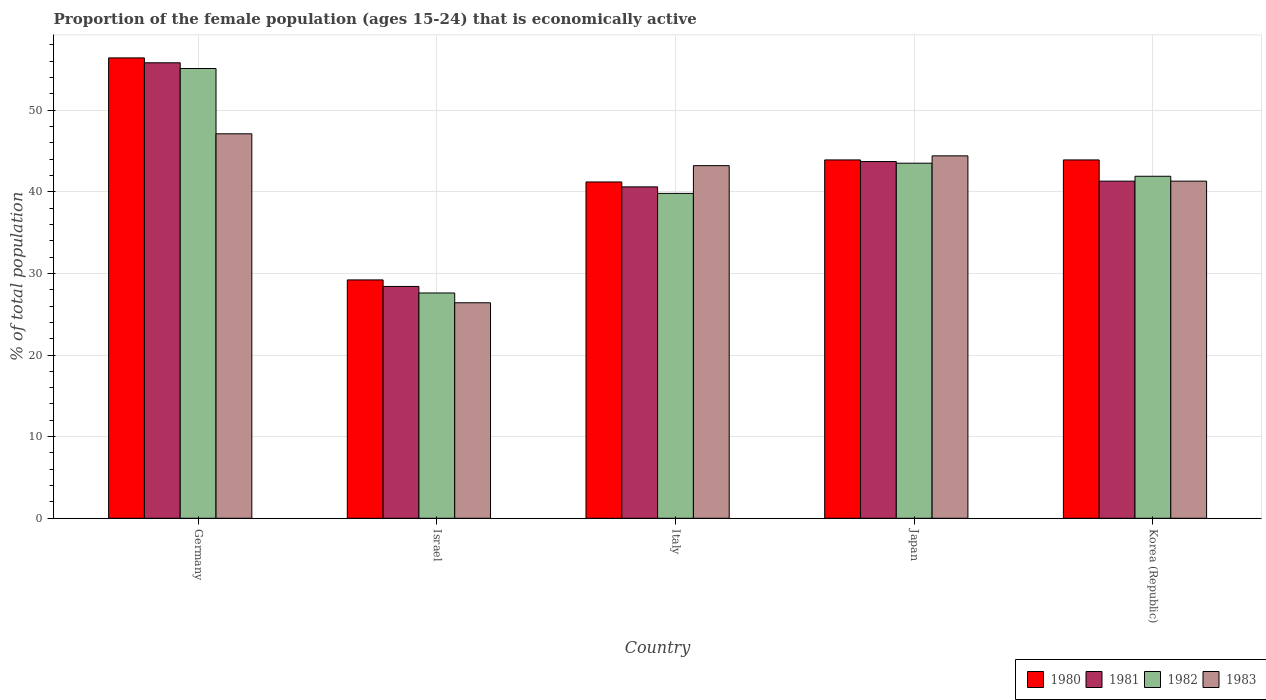How many groups of bars are there?
Keep it short and to the point. 5. Are the number of bars per tick equal to the number of legend labels?
Offer a very short reply. Yes. How many bars are there on the 1st tick from the left?
Provide a succinct answer. 4. How many bars are there on the 1st tick from the right?
Make the answer very short. 4. What is the label of the 5th group of bars from the left?
Make the answer very short. Korea (Republic). What is the proportion of the female population that is economically active in 1983 in Israel?
Your response must be concise. 26.4. Across all countries, what is the maximum proportion of the female population that is economically active in 1980?
Offer a terse response. 56.4. Across all countries, what is the minimum proportion of the female population that is economically active in 1981?
Offer a very short reply. 28.4. What is the total proportion of the female population that is economically active in 1980 in the graph?
Your answer should be compact. 214.6. What is the difference between the proportion of the female population that is economically active in 1983 in Germany and that in Israel?
Your response must be concise. 20.7. What is the difference between the proportion of the female population that is economically active in 1980 in Japan and the proportion of the female population that is economically active in 1982 in Germany?
Offer a very short reply. -11.2. What is the average proportion of the female population that is economically active in 1980 per country?
Give a very brief answer. 42.92. What is the difference between the proportion of the female population that is economically active of/in 1981 and proportion of the female population that is economically active of/in 1982 in Japan?
Provide a short and direct response. 0.2. What is the ratio of the proportion of the female population that is economically active in 1983 in Italy to that in Korea (Republic)?
Your answer should be compact. 1.05. What is the difference between the highest and the second highest proportion of the female population that is economically active in 1981?
Offer a very short reply. -2.4. What is the difference between the highest and the lowest proportion of the female population that is economically active in 1980?
Your response must be concise. 27.2. In how many countries, is the proportion of the female population that is economically active in 1980 greater than the average proportion of the female population that is economically active in 1980 taken over all countries?
Your answer should be compact. 3. Is the sum of the proportion of the female population that is economically active in 1981 in Israel and Italy greater than the maximum proportion of the female population that is economically active in 1983 across all countries?
Make the answer very short. Yes. Is it the case that in every country, the sum of the proportion of the female population that is economically active in 1982 and proportion of the female population that is economically active in 1980 is greater than the sum of proportion of the female population that is economically active in 1981 and proportion of the female population that is economically active in 1983?
Offer a very short reply. No. What does the 2nd bar from the left in Japan represents?
Your response must be concise. 1981. Is it the case that in every country, the sum of the proportion of the female population that is economically active in 1980 and proportion of the female population that is economically active in 1982 is greater than the proportion of the female population that is economically active in 1981?
Make the answer very short. Yes. How many countries are there in the graph?
Offer a terse response. 5. Are the values on the major ticks of Y-axis written in scientific E-notation?
Give a very brief answer. No. Does the graph contain any zero values?
Give a very brief answer. No. Does the graph contain grids?
Keep it short and to the point. Yes. Where does the legend appear in the graph?
Make the answer very short. Bottom right. How are the legend labels stacked?
Offer a terse response. Horizontal. What is the title of the graph?
Provide a succinct answer. Proportion of the female population (ages 15-24) that is economically active. What is the label or title of the X-axis?
Your answer should be compact. Country. What is the label or title of the Y-axis?
Provide a short and direct response. % of total population. What is the % of total population of 1980 in Germany?
Ensure brevity in your answer.  56.4. What is the % of total population of 1981 in Germany?
Give a very brief answer. 55.8. What is the % of total population of 1982 in Germany?
Keep it short and to the point. 55.1. What is the % of total population in 1983 in Germany?
Keep it short and to the point. 47.1. What is the % of total population of 1980 in Israel?
Give a very brief answer. 29.2. What is the % of total population of 1981 in Israel?
Make the answer very short. 28.4. What is the % of total population in 1982 in Israel?
Offer a terse response. 27.6. What is the % of total population of 1983 in Israel?
Provide a short and direct response. 26.4. What is the % of total population in 1980 in Italy?
Your response must be concise. 41.2. What is the % of total population of 1981 in Italy?
Your response must be concise. 40.6. What is the % of total population of 1982 in Italy?
Your answer should be very brief. 39.8. What is the % of total population of 1983 in Italy?
Provide a short and direct response. 43.2. What is the % of total population in 1980 in Japan?
Your answer should be compact. 43.9. What is the % of total population of 1981 in Japan?
Offer a terse response. 43.7. What is the % of total population in 1982 in Japan?
Provide a succinct answer. 43.5. What is the % of total population of 1983 in Japan?
Provide a short and direct response. 44.4. What is the % of total population of 1980 in Korea (Republic)?
Make the answer very short. 43.9. What is the % of total population of 1981 in Korea (Republic)?
Your answer should be compact. 41.3. What is the % of total population in 1982 in Korea (Republic)?
Your response must be concise. 41.9. What is the % of total population in 1983 in Korea (Republic)?
Make the answer very short. 41.3. Across all countries, what is the maximum % of total population in 1980?
Make the answer very short. 56.4. Across all countries, what is the maximum % of total population of 1981?
Your answer should be compact. 55.8. Across all countries, what is the maximum % of total population in 1982?
Offer a terse response. 55.1. Across all countries, what is the maximum % of total population in 1983?
Ensure brevity in your answer.  47.1. Across all countries, what is the minimum % of total population in 1980?
Offer a very short reply. 29.2. Across all countries, what is the minimum % of total population of 1981?
Your answer should be compact. 28.4. Across all countries, what is the minimum % of total population of 1982?
Offer a very short reply. 27.6. Across all countries, what is the minimum % of total population of 1983?
Provide a succinct answer. 26.4. What is the total % of total population of 1980 in the graph?
Your answer should be very brief. 214.6. What is the total % of total population in 1981 in the graph?
Your response must be concise. 209.8. What is the total % of total population of 1982 in the graph?
Ensure brevity in your answer.  207.9. What is the total % of total population of 1983 in the graph?
Offer a terse response. 202.4. What is the difference between the % of total population in 1980 in Germany and that in Israel?
Provide a short and direct response. 27.2. What is the difference between the % of total population of 1981 in Germany and that in Israel?
Your answer should be compact. 27.4. What is the difference between the % of total population of 1982 in Germany and that in Israel?
Ensure brevity in your answer.  27.5. What is the difference between the % of total population in 1983 in Germany and that in Israel?
Keep it short and to the point. 20.7. What is the difference between the % of total population in 1981 in Germany and that in Italy?
Your answer should be compact. 15.2. What is the difference between the % of total population in 1980 in Germany and that in Japan?
Give a very brief answer. 12.5. What is the difference between the % of total population in 1982 in Germany and that in Japan?
Your response must be concise. 11.6. What is the difference between the % of total population in 1983 in Germany and that in Japan?
Offer a very short reply. 2.7. What is the difference between the % of total population in 1981 in Germany and that in Korea (Republic)?
Ensure brevity in your answer.  14.5. What is the difference between the % of total population of 1982 in Germany and that in Korea (Republic)?
Offer a very short reply. 13.2. What is the difference between the % of total population in 1981 in Israel and that in Italy?
Provide a succinct answer. -12.2. What is the difference between the % of total population in 1983 in Israel and that in Italy?
Your response must be concise. -16.8. What is the difference between the % of total population in 1980 in Israel and that in Japan?
Give a very brief answer. -14.7. What is the difference between the % of total population in 1981 in Israel and that in Japan?
Give a very brief answer. -15.3. What is the difference between the % of total population in 1982 in Israel and that in Japan?
Ensure brevity in your answer.  -15.9. What is the difference between the % of total population of 1983 in Israel and that in Japan?
Provide a short and direct response. -18. What is the difference between the % of total population of 1980 in Israel and that in Korea (Republic)?
Ensure brevity in your answer.  -14.7. What is the difference between the % of total population of 1982 in Israel and that in Korea (Republic)?
Offer a terse response. -14.3. What is the difference between the % of total population of 1983 in Israel and that in Korea (Republic)?
Offer a very short reply. -14.9. What is the difference between the % of total population in 1981 in Italy and that in Japan?
Ensure brevity in your answer.  -3.1. What is the difference between the % of total population in 1982 in Italy and that in Japan?
Give a very brief answer. -3.7. What is the difference between the % of total population of 1983 in Italy and that in Japan?
Ensure brevity in your answer.  -1.2. What is the difference between the % of total population in 1982 in Italy and that in Korea (Republic)?
Your response must be concise. -2.1. What is the difference between the % of total population of 1980 in Japan and that in Korea (Republic)?
Offer a very short reply. 0. What is the difference between the % of total population in 1981 in Japan and that in Korea (Republic)?
Keep it short and to the point. 2.4. What is the difference between the % of total population in 1980 in Germany and the % of total population in 1981 in Israel?
Your response must be concise. 28. What is the difference between the % of total population in 1980 in Germany and the % of total population in 1982 in Israel?
Your answer should be very brief. 28.8. What is the difference between the % of total population in 1981 in Germany and the % of total population in 1982 in Israel?
Offer a very short reply. 28.2. What is the difference between the % of total population of 1981 in Germany and the % of total population of 1983 in Israel?
Your response must be concise. 29.4. What is the difference between the % of total population in 1982 in Germany and the % of total population in 1983 in Israel?
Your response must be concise. 28.7. What is the difference between the % of total population of 1980 in Germany and the % of total population of 1981 in Italy?
Your response must be concise. 15.8. What is the difference between the % of total population in 1980 in Germany and the % of total population in 1982 in Italy?
Give a very brief answer. 16.6. What is the difference between the % of total population in 1981 in Germany and the % of total population in 1983 in Italy?
Give a very brief answer. 12.6. What is the difference between the % of total population of 1980 in Germany and the % of total population of 1982 in Japan?
Offer a very short reply. 12.9. What is the difference between the % of total population of 1980 in Germany and the % of total population of 1983 in Japan?
Provide a succinct answer. 12. What is the difference between the % of total population in 1982 in Germany and the % of total population in 1983 in Japan?
Provide a succinct answer. 10.7. What is the difference between the % of total population of 1980 in Germany and the % of total population of 1981 in Korea (Republic)?
Give a very brief answer. 15.1. What is the difference between the % of total population in 1980 in Germany and the % of total population in 1982 in Korea (Republic)?
Offer a terse response. 14.5. What is the difference between the % of total population in 1981 in Germany and the % of total population in 1982 in Korea (Republic)?
Your answer should be compact. 13.9. What is the difference between the % of total population of 1980 in Israel and the % of total population of 1982 in Italy?
Keep it short and to the point. -10.6. What is the difference between the % of total population in 1981 in Israel and the % of total population in 1982 in Italy?
Ensure brevity in your answer.  -11.4. What is the difference between the % of total population of 1981 in Israel and the % of total population of 1983 in Italy?
Provide a succinct answer. -14.8. What is the difference between the % of total population in 1982 in Israel and the % of total population in 1983 in Italy?
Give a very brief answer. -15.6. What is the difference between the % of total population of 1980 in Israel and the % of total population of 1982 in Japan?
Give a very brief answer. -14.3. What is the difference between the % of total population in 1980 in Israel and the % of total population in 1983 in Japan?
Your answer should be very brief. -15.2. What is the difference between the % of total population of 1981 in Israel and the % of total population of 1982 in Japan?
Provide a succinct answer. -15.1. What is the difference between the % of total population of 1982 in Israel and the % of total population of 1983 in Japan?
Provide a succinct answer. -16.8. What is the difference between the % of total population in 1980 in Israel and the % of total population in 1982 in Korea (Republic)?
Provide a succinct answer. -12.7. What is the difference between the % of total population in 1981 in Israel and the % of total population in 1983 in Korea (Republic)?
Your response must be concise. -12.9. What is the difference between the % of total population of 1982 in Israel and the % of total population of 1983 in Korea (Republic)?
Give a very brief answer. -13.7. What is the difference between the % of total population in 1982 in Italy and the % of total population in 1983 in Japan?
Your answer should be very brief. -4.6. What is the difference between the % of total population of 1980 in Italy and the % of total population of 1983 in Korea (Republic)?
Offer a very short reply. -0.1. What is the difference between the % of total population of 1981 in Italy and the % of total population of 1982 in Korea (Republic)?
Offer a terse response. -1.3. What is the difference between the % of total population in 1981 in Italy and the % of total population in 1983 in Korea (Republic)?
Offer a terse response. -0.7. What is the difference between the % of total population in 1980 in Japan and the % of total population in 1981 in Korea (Republic)?
Keep it short and to the point. 2.6. What is the difference between the % of total population of 1980 in Japan and the % of total population of 1982 in Korea (Republic)?
Provide a short and direct response. 2. What is the difference between the % of total population of 1981 in Japan and the % of total population of 1983 in Korea (Republic)?
Keep it short and to the point. 2.4. What is the average % of total population in 1980 per country?
Your response must be concise. 42.92. What is the average % of total population of 1981 per country?
Give a very brief answer. 41.96. What is the average % of total population in 1982 per country?
Offer a terse response. 41.58. What is the average % of total population of 1983 per country?
Your answer should be very brief. 40.48. What is the difference between the % of total population in 1980 and % of total population in 1982 in Germany?
Offer a terse response. 1.3. What is the difference between the % of total population in 1982 and % of total population in 1983 in Germany?
Your answer should be compact. 8. What is the difference between the % of total population of 1980 and % of total population of 1983 in Israel?
Your response must be concise. 2.8. What is the difference between the % of total population of 1981 and % of total population of 1982 in Israel?
Your answer should be compact. 0.8. What is the difference between the % of total population in 1981 and % of total population in 1983 in Israel?
Your response must be concise. 2. What is the difference between the % of total population of 1980 and % of total population of 1981 in Italy?
Your response must be concise. 0.6. What is the difference between the % of total population of 1980 and % of total population of 1983 in Italy?
Provide a succinct answer. -2. What is the difference between the % of total population of 1980 and % of total population of 1981 in Japan?
Your answer should be very brief. 0.2. What is the difference between the % of total population of 1980 and % of total population of 1982 in Japan?
Offer a very short reply. 0.4. What is the difference between the % of total population of 1980 and % of total population of 1983 in Japan?
Provide a succinct answer. -0.5. What is the difference between the % of total population in 1981 and % of total population in 1982 in Japan?
Your response must be concise. 0.2. What is the difference between the % of total population of 1980 and % of total population of 1981 in Korea (Republic)?
Provide a succinct answer. 2.6. What is the difference between the % of total population in 1981 and % of total population in 1982 in Korea (Republic)?
Keep it short and to the point. -0.6. What is the difference between the % of total population in 1981 and % of total population in 1983 in Korea (Republic)?
Your answer should be very brief. 0. What is the ratio of the % of total population in 1980 in Germany to that in Israel?
Make the answer very short. 1.93. What is the ratio of the % of total population of 1981 in Germany to that in Israel?
Make the answer very short. 1.96. What is the ratio of the % of total population in 1982 in Germany to that in Israel?
Give a very brief answer. 2. What is the ratio of the % of total population in 1983 in Germany to that in Israel?
Make the answer very short. 1.78. What is the ratio of the % of total population of 1980 in Germany to that in Italy?
Provide a short and direct response. 1.37. What is the ratio of the % of total population in 1981 in Germany to that in Italy?
Make the answer very short. 1.37. What is the ratio of the % of total population in 1982 in Germany to that in Italy?
Your response must be concise. 1.38. What is the ratio of the % of total population of 1983 in Germany to that in Italy?
Offer a terse response. 1.09. What is the ratio of the % of total population in 1980 in Germany to that in Japan?
Give a very brief answer. 1.28. What is the ratio of the % of total population in 1981 in Germany to that in Japan?
Keep it short and to the point. 1.28. What is the ratio of the % of total population in 1982 in Germany to that in Japan?
Ensure brevity in your answer.  1.27. What is the ratio of the % of total population of 1983 in Germany to that in Japan?
Ensure brevity in your answer.  1.06. What is the ratio of the % of total population in 1980 in Germany to that in Korea (Republic)?
Your answer should be compact. 1.28. What is the ratio of the % of total population in 1981 in Germany to that in Korea (Republic)?
Provide a succinct answer. 1.35. What is the ratio of the % of total population of 1982 in Germany to that in Korea (Republic)?
Keep it short and to the point. 1.31. What is the ratio of the % of total population in 1983 in Germany to that in Korea (Republic)?
Provide a succinct answer. 1.14. What is the ratio of the % of total population of 1980 in Israel to that in Italy?
Give a very brief answer. 0.71. What is the ratio of the % of total population in 1981 in Israel to that in Italy?
Your answer should be very brief. 0.7. What is the ratio of the % of total population in 1982 in Israel to that in Italy?
Keep it short and to the point. 0.69. What is the ratio of the % of total population in 1983 in Israel to that in Italy?
Provide a succinct answer. 0.61. What is the ratio of the % of total population of 1980 in Israel to that in Japan?
Offer a very short reply. 0.67. What is the ratio of the % of total population of 1981 in Israel to that in Japan?
Provide a succinct answer. 0.65. What is the ratio of the % of total population in 1982 in Israel to that in Japan?
Your answer should be compact. 0.63. What is the ratio of the % of total population in 1983 in Israel to that in Japan?
Make the answer very short. 0.59. What is the ratio of the % of total population of 1980 in Israel to that in Korea (Republic)?
Your answer should be compact. 0.67. What is the ratio of the % of total population in 1981 in Israel to that in Korea (Republic)?
Offer a very short reply. 0.69. What is the ratio of the % of total population in 1982 in Israel to that in Korea (Republic)?
Provide a short and direct response. 0.66. What is the ratio of the % of total population in 1983 in Israel to that in Korea (Republic)?
Offer a terse response. 0.64. What is the ratio of the % of total population of 1980 in Italy to that in Japan?
Provide a short and direct response. 0.94. What is the ratio of the % of total population of 1981 in Italy to that in Japan?
Offer a terse response. 0.93. What is the ratio of the % of total population in 1982 in Italy to that in Japan?
Your response must be concise. 0.91. What is the ratio of the % of total population of 1983 in Italy to that in Japan?
Make the answer very short. 0.97. What is the ratio of the % of total population of 1980 in Italy to that in Korea (Republic)?
Provide a succinct answer. 0.94. What is the ratio of the % of total population of 1981 in Italy to that in Korea (Republic)?
Your answer should be very brief. 0.98. What is the ratio of the % of total population of 1982 in Italy to that in Korea (Republic)?
Your answer should be very brief. 0.95. What is the ratio of the % of total population of 1983 in Italy to that in Korea (Republic)?
Provide a short and direct response. 1.05. What is the ratio of the % of total population in 1980 in Japan to that in Korea (Republic)?
Your answer should be very brief. 1. What is the ratio of the % of total population of 1981 in Japan to that in Korea (Republic)?
Give a very brief answer. 1.06. What is the ratio of the % of total population of 1982 in Japan to that in Korea (Republic)?
Keep it short and to the point. 1.04. What is the ratio of the % of total population of 1983 in Japan to that in Korea (Republic)?
Give a very brief answer. 1.08. What is the difference between the highest and the second highest % of total population of 1982?
Your response must be concise. 11.6. What is the difference between the highest and the second highest % of total population of 1983?
Your answer should be compact. 2.7. What is the difference between the highest and the lowest % of total population in 1980?
Your answer should be compact. 27.2. What is the difference between the highest and the lowest % of total population in 1981?
Provide a succinct answer. 27.4. What is the difference between the highest and the lowest % of total population of 1983?
Provide a short and direct response. 20.7. 